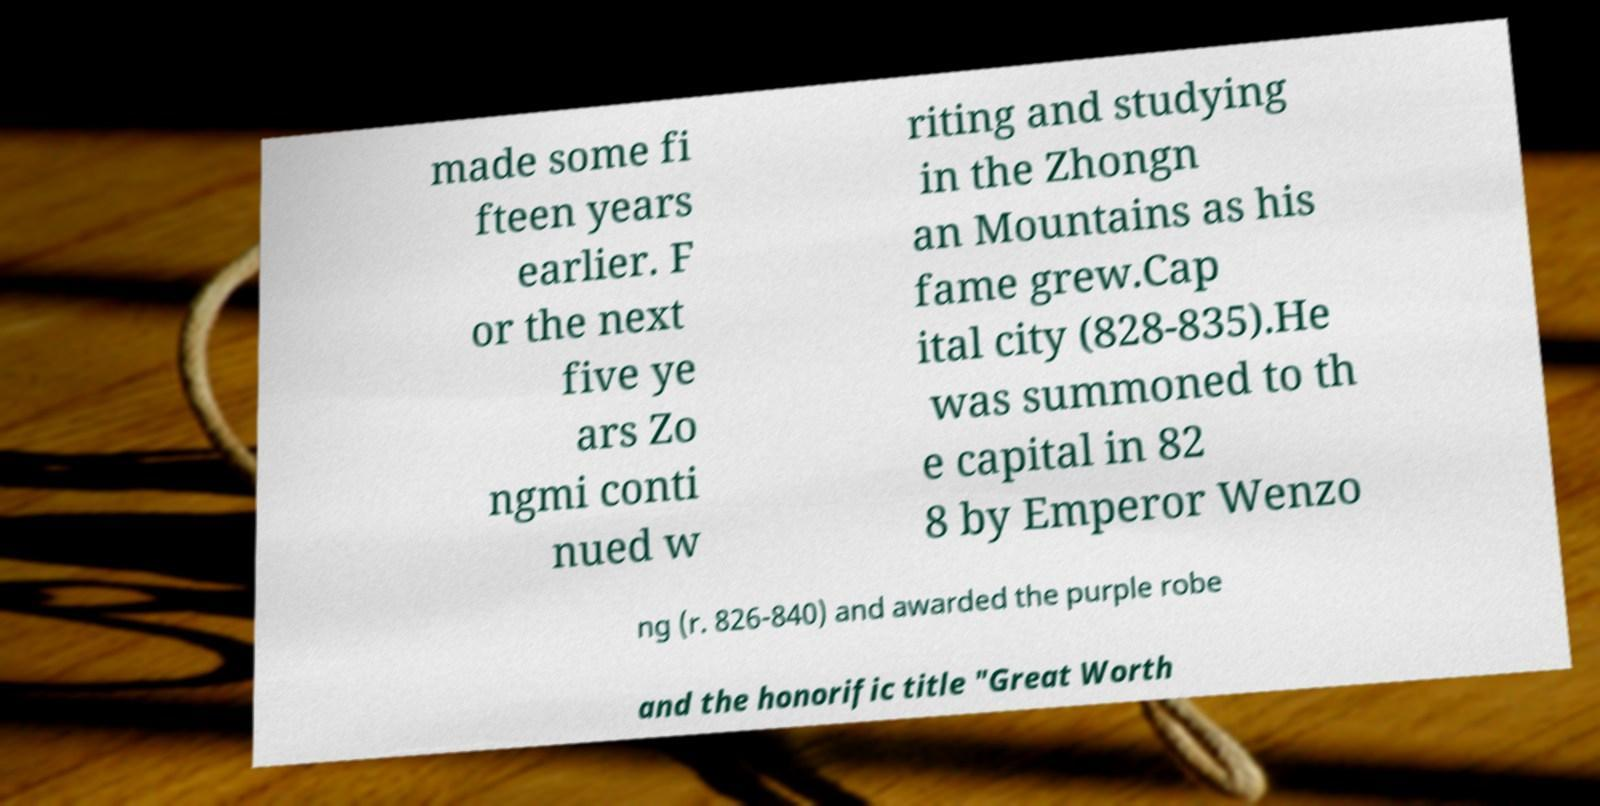Could you extract and type out the text from this image? made some fi fteen years earlier. F or the next five ye ars Zo ngmi conti nued w riting and studying in the Zhongn an Mountains as his fame grew.Cap ital city (828-835).He was summoned to th e capital in 82 8 by Emperor Wenzo ng (r. 826-840) and awarded the purple robe and the honorific title "Great Worth 